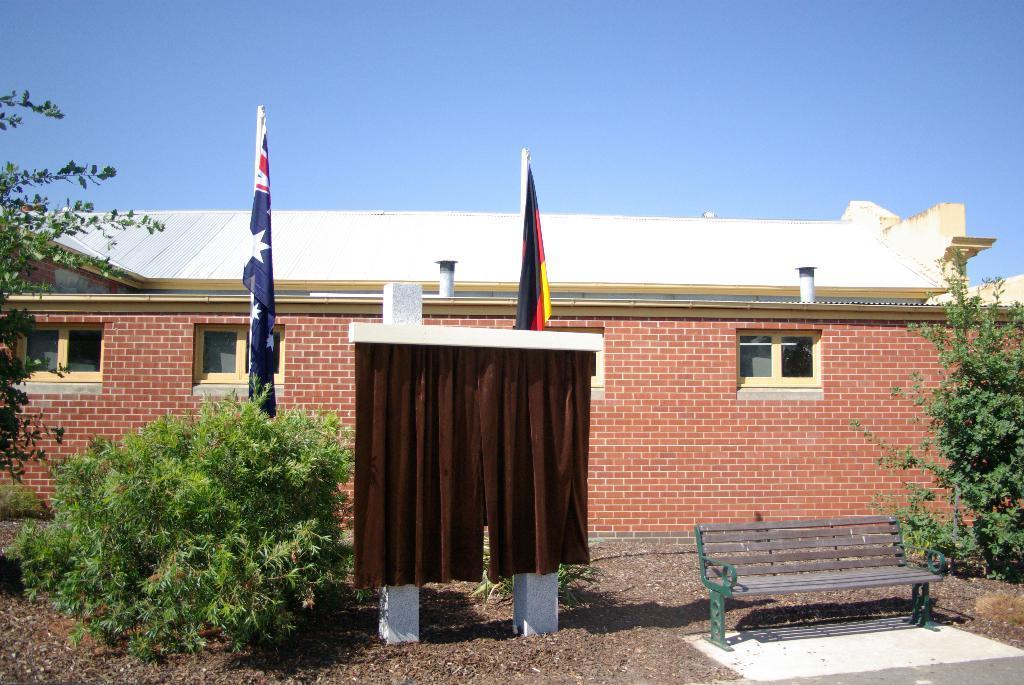Describe this image in one or two sentences. This is a building with roof top. This wall are made with bricks. These are plants. This is a bench. Backside of this curtains there are flags. Sky is in blue color. 